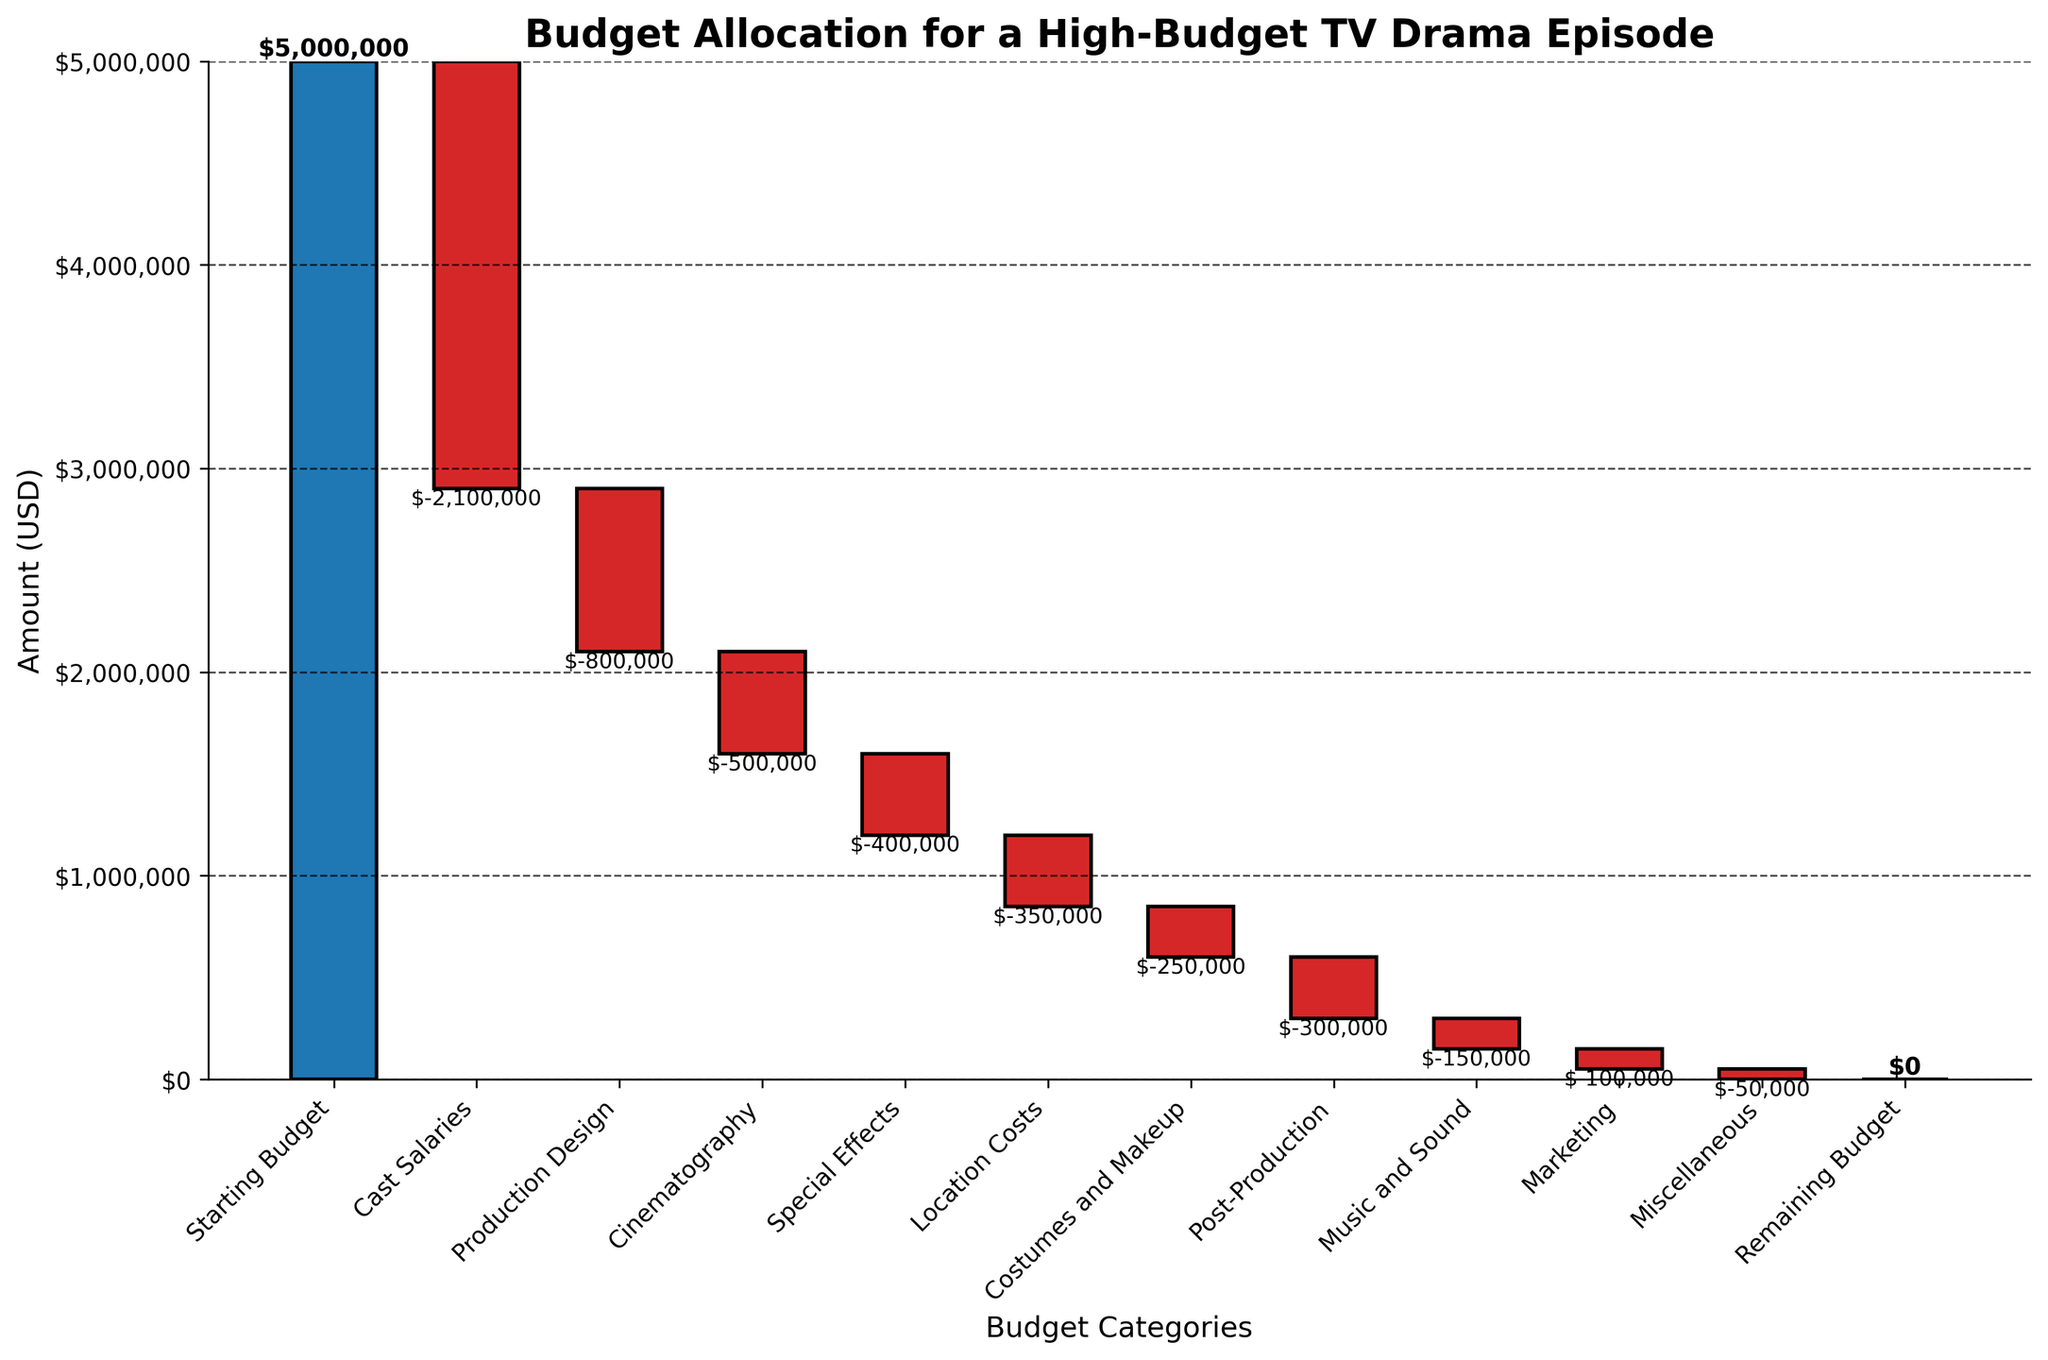What's the total budget allocated for cast salaries and production design? First, identify the values for cast salaries (-$2,100,000) and production design (-$800,000). Then sum these amounts: -$2,100,000 + -$800,000 = -$2,900,000
Answer: $-2,900,000 Which category received the least amount of budget? Scan through the categories and their corresponding values. The category with the least budget is Miscellaneous with -$50,000.
Answer: Miscellaneous How much budget remains after accounting for all expenses except marketing? Sum only the values of the categories before marketing and subtract from the starting budget:
$5,000,000 - ($2,100,000 + $800,000 + $500,000 + $400,000 + $350,000 + $250,000 + $300,000 + $150,000) = $150,000
Answer: $150,000 What is the difference between the budgets allocated for cinematography and special effects? Subtract the budget for special effects (-$400,000) from the budget for cinematography (-$500,000): -$500,000 - (-$400,000) = -$100,000
Answer: $-100,000 How does the budget for location costs compare to the budget for costumes and makeup? Compare the values for location costs (-$350,000) and costumes and makeup (-$250,000). The value for location costs is more negative than the value for costumes and makeup.
Location costs have a higher budget allocation than costumes and makeup since -$350,000 < -$250,000
Answer: Location costs have a higher budget allocation How many budget categories are included in the chart? Count all the categories starting from "Starting Budget" up to "Remaining Budget." There are 11 categories in total.
Answer: 11 What’s the overall trend in the budget allocation from the starting to the remaining budget? The waterfall chart shows a gradual decline in budget from the starting amount as expenses are subtracted, leading to a remaining budget of $0. This indicates that all of the starting budget is allocated to the various expenses.
Answer: Decreasing trend to $0 What are the three largest expenses in the budget? Identify the categories with the most significant negative values: Cast Salaries (-$2,100,000), Production Design (-$800,000), and Cinematography (-$500,000).
Answer: Cast Salaries, Production Design, Cinematography What category would you target for budget cuts to possibly increase the remaining budget? Consider categories with relatively smaller negative values where cuts may be feasible: Marketing (-$100,000) and Miscellaneous (-$50,000). These are smaller expenses that could be reduced to increase the remaining budget up to these amounts.
Answer: Marketing or Miscellaneous How would a 10% increase in the budget affect the remaining budget? First, calculate 10% of the starting budget: 10% of $5,000,000 = $500,000. Add this increase to the starting budget, resulting in a new starting budget of $5,500,000. Since all other expenses remain unchanged, the remaining budget would increase by $500,000 from $0 to $500,000.
Answer: $500,000 